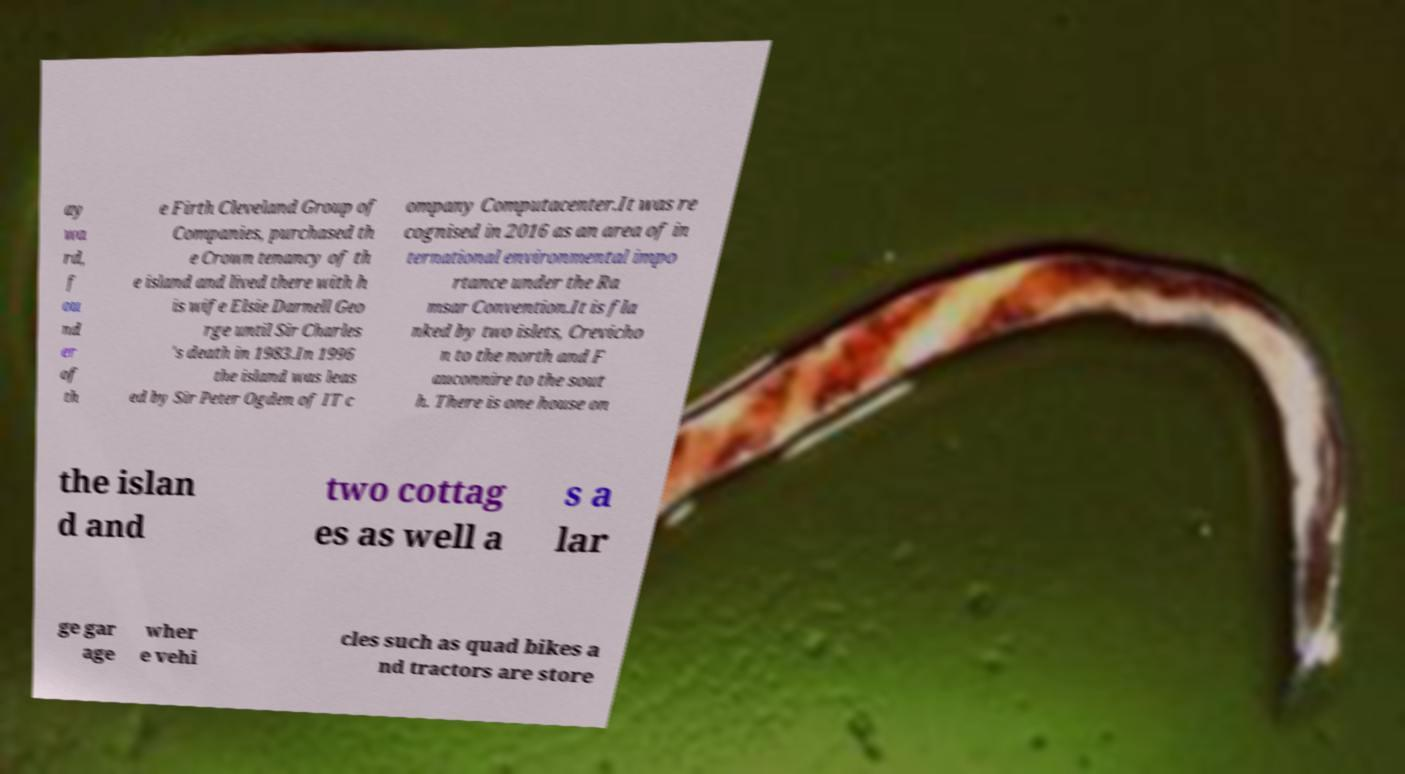Could you assist in decoding the text presented in this image and type it out clearly? ay wa rd, f ou nd er of th e Firth Cleveland Group of Companies, purchased th e Crown tenancy of th e island and lived there with h is wife Elsie Darnell Geo rge until Sir Charles 's death in 1983.In 1996 the island was leas ed by Sir Peter Ogden of IT c ompany Computacenter.It was re cognised in 2016 as an area of in ternational environmental impo rtance under the Ra msar Convention.It is fla nked by two islets, Crevicho n to the north and F auconnire to the sout h. There is one house on the islan d and two cottag es as well a s a lar ge gar age wher e vehi cles such as quad bikes a nd tractors are store 